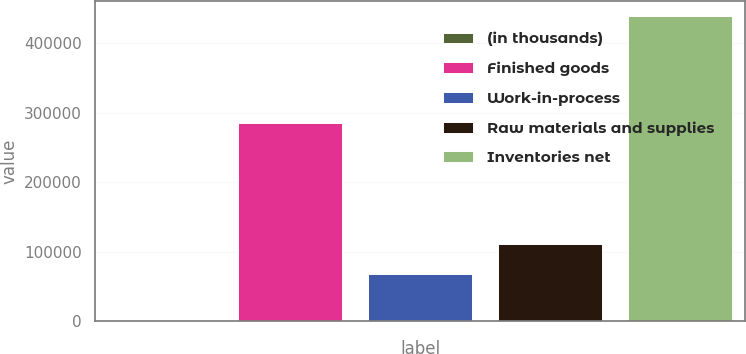Convert chart. <chart><loc_0><loc_0><loc_500><loc_500><bar_chart><fcel>(in thousands)<fcel>Finished goods<fcel>Work-in-process<fcel>Raw materials and supplies<fcel>Inventories net<nl><fcel>2013<fcel>285271<fcel>67718<fcel>111373<fcel>438559<nl></chart> 